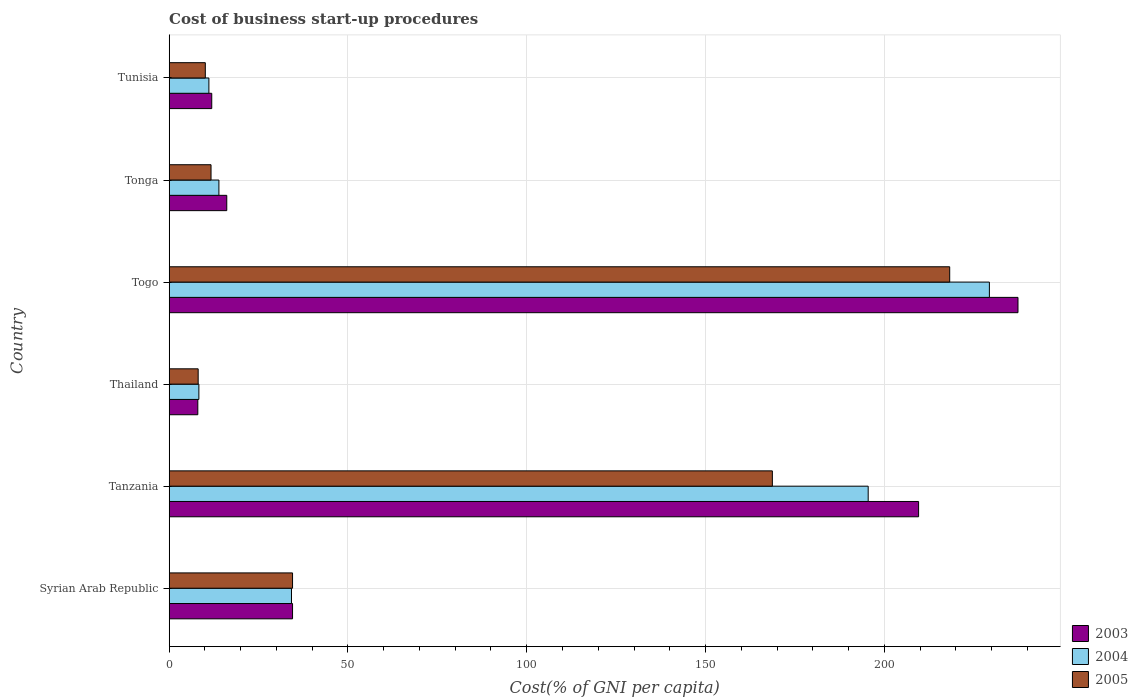How many different coloured bars are there?
Make the answer very short. 3. Are the number of bars per tick equal to the number of legend labels?
Make the answer very short. Yes. How many bars are there on the 3rd tick from the bottom?
Offer a terse response. 3. What is the label of the 5th group of bars from the top?
Your answer should be compact. Tanzania. What is the cost of business start-up procedures in 2004 in Togo?
Your response must be concise. 229.4. Across all countries, what is the maximum cost of business start-up procedures in 2003?
Your response must be concise. 237.4. In which country was the cost of business start-up procedures in 2003 maximum?
Your answer should be very brief. Togo. In which country was the cost of business start-up procedures in 2004 minimum?
Your response must be concise. Thailand. What is the total cost of business start-up procedures in 2003 in the graph?
Offer a terse response. 517.5. What is the difference between the cost of business start-up procedures in 2003 in Tonga and that in Tunisia?
Ensure brevity in your answer.  4.2. What is the difference between the cost of business start-up procedures in 2003 in Thailand and the cost of business start-up procedures in 2005 in Tunisia?
Offer a very short reply. -2.1. What is the average cost of business start-up procedures in 2005 per country?
Offer a very short reply. 75.23. What is the difference between the cost of business start-up procedures in 2003 and cost of business start-up procedures in 2005 in Tunisia?
Provide a succinct answer. 1.8. In how many countries, is the cost of business start-up procedures in 2004 greater than 20 %?
Your answer should be very brief. 3. What is the ratio of the cost of business start-up procedures in 2004 in Syrian Arab Republic to that in Thailand?
Your answer should be very brief. 4.12. Is the cost of business start-up procedures in 2003 in Togo less than that in Tunisia?
Make the answer very short. No. Is the difference between the cost of business start-up procedures in 2003 in Thailand and Tonga greater than the difference between the cost of business start-up procedures in 2005 in Thailand and Tonga?
Give a very brief answer. No. What is the difference between the highest and the second highest cost of business start-up procedures in 2005?
Give a very brief answer. 49.6. What is the difference between the highest and the lowest cost of business start-up procedures in 2005?
Keep it short and to the point. 210.2. Is the sum of the cost of business start-up procedures in 2005 in Tanzania and Tonga greater than the maximum cost of business start-up procedures in 2004 across all countries?
Ensure brevity in your answer.  No. Is it the case that in every country, the sum of the cost of business start-up procedures in 2005 and cost of business start-up procedures in 2004 is greater than the cost of business start-up procedures in 2003?
Keep it short and to the point. Yes. How many bars are there?
Offer a terse response. 18. Are all the bars in the graph horizontal?
Your answer should be very brief. Yes. Are the values on the major ticks of X-axis written in scientific E-notation?
Ensure brevity in your answer.  No. Does the graph contain any zero values?
Provide a succinct answer. No. Does the graph contain grids?
Give a very brief answer. Yes. Where does the legend appear in the graph?
Keep it short and to the point. Bottom right. How are the legend labels stacked?
Ensure brevity in your answer.  Vertical. What is the title of the graph?
Your response must be concise. Cost of business start-up procedures. What is the label or title of the X-axis?
Provide a short and direct response. Cost(% of GNI per capita). What is the Cost(% of GNI per capita) of 2003 in Syrian Arab Republic?
Your answer should be very brief. 34.5. What is the Cost(% of GNI per capita) of 2004 in Syrian Arab Republic?
Ensure brevity in your answer.  34.2. What is the Cost(% of GNI per capita) of 2005 in Syrian Arab Republic?
Keep it short and to the point. 34.5. What is the Cost(% of GNI per capita) of 2003 in Tanzania?
Offer a very short reply. 209.6. What is the Cost(% of GNI per capita) in 2004 in Tanzania?
Keep it short and to the point. 195.5. What is the Cost(% of GNI per capita) of 2005 in Tanzania?
Your response must be concise. 168.7. What is the Cost(% of GNI per capita) of 2003 in Togo?
Offer a terse response. 237.4. What is the Cost(% of GNI per capita) of 2004 in Togo?
Provide a succinct answer. 229.4. What is the Cost(% of GNI per capita) of 2005 in Togo?
Offer a very short reply. 218.3. What is the Cost(% of GNI per capita) of 2003 in Tonga?
Your answer should be very brief. 16.1. What is the Cost(% of GNI per capita) of 2005 in Tonga?
Provide a succinct answer. 11.7. What is the Cost(% of GNI per capita) of 2003 in Tunisia?
Keep it short and to the point. 11.9. What is the Cost(% of GNI per capita) of 2005 in Tunisia?
Your answer should be compact. 10.1. Across all countries, what is the maximum Cost(% of GNI per capita) in 2003?
Offer a very short reply. 237.4. Across all countries, what is the maximum Cost(% of GNI per capita) of 2004?
Your response must be concise. 229.4. Across all countries, what is the maximum Cost(% of GNI per capita) of 2005?
Your answer should be compact. 218.3. Across all countries, what is the minimum Cost(% of GNI per capita) in 2005?
Your answer should be very brief. 8.1. What is the total Cost(% of GNI per capita) in 2003 in the graph?
Your answer should be compact. 517.5. What is the total Cost(% of GNI per capita) of 2004 in the graph?
Ensure brevity in your answer.  492.4. What is the total Cost(% of GNI per capita) of 2005 in the graph?
Provide a succinct answer. 451.4. What is the difference between the Cost(% of GNI per capita) in 2003 in Syrian Arab Republic and that in Tanzania?
Provide a succinct answer. -175.1. What is the difference between the Cost(% of GNI per capita) of 2004 in Syrian Arab Republic and that in Tanzania?
Provide a succinct answer. -161.3. What is the difference between the Cost(% of GNI per capita) in 2005 in Syrian Arab Republic and that in Tanzania?
Make the answer very short. -134.2. What is the difference between the Cost(% of GNI per capita) in 2004 in Syrian Arab Republic and that in Thailand?
Provide a short and direct response. 25.9. What is the difference between the Cost(% of GNI per capita) in 2005 in Syrian Arab Republic and that in Thailand?
Ensure brevity in your answer.  26.4. What is the difference between the Cost(% of GNI per capita) of 2003 in Syrian Arab Republic and that in Togo?
Provide a succinct answer. -202.9. What is the difference between the Cost(% of GNI per capita) of 2004 in Syrian Arab Republic and that in Togo?
Your answer should be compact. -195.2. What is the difference between the Cost(% of GNI per capita) of 2005 in Syrian Arab Republic and that in Togo?
Provide a succinct answer. -183.8. What is the difference between the Cost(% of GNI per capita) in 2004 in Syrian Arab Republic and that in Tonga?
Your response must be concise. 20.3. What is the difference between the Cost(% of GNI per capita) of 2005 in Syrian Arab Republic and that in Tonga?
Ensure brevity in your answer.  22.8. What is the difference between the Cost(% of GNI per capita) of 2003 in Syrian Arab Republic and that in Tunisia?
Provide a short and direct response. 22.6. What is the difference between the Cost(% of GNI per capita) of 2004 in Syrian Arab Republic and that in Tunisia?
Your answer should be very brief. 23.1. What is the difference between the Cost(% of GNI per capita) of 2005 in Syrian Arab Republic and that in Tunisia?
Keep it short and to the point. 24.4. What is the difference between the Cost(% of GNI per capita) in 2003 in Tanzania and that in Thailand?
Offer a terse response. 201.6. What is the difference between the Cost(% of GNI per capita) of 2004 in Tanzania and that in Thailand?
Give a very brief answer. 187.2. What is the difference between the Cost(% of GNI per capita) in 2005 in Tanzania and that in Thailand?
Make the answer very short. 160.6. What is the difference between the Cost(% of GNI per capita) of 2003 in Tanzania and that in Togo?
Provide a succinct answer. -27.8. What is the difference between the Cost(% of GNI per capita) in 2004 in Tanzania and that in Togo?
Offer a very short reply. -33.9. What is the difference between the Cost(% of GNI per capita) in 2005 in Tanzania and that in Togo?
Provide a succinct answer. -49.6. What is the difference between the Cost(% of GNI per capita) of 2003 in Tanzania and that in Tonga?
Ensure brevity in your answer.  193.5. What is the difference between the Cost(% of GNI per capita) in 2004 in Tanzania and that in Tonga?
Your answer should be compact. 181.6. What is the difference between the Cost(% of GNI per capita) in 2005 in Tanzania and that in Tonga?
Ensure brevity in your answer.  157. What is the difference between the Cost(% of GNI per capita) in 2003 in Tanzania and that in Tunisia?
Make the answer very short. 197.7. What is the difference between the Cost(% of GNI per capita) of 2004 in Tanzania and that in Tunisia?
Provide a succinct answer. 184.4. What is the difference between the Cost(% of GNI per capita) of 2005 in Tanzania and that in Tunisia?
Your response must be concise. 158.6. What is the difference between the Cost(% of GNI per capita) of 2003 in Thailand and that in Togo?
Your answer should be very brief. -229.4. What is the difference between the Cost(% of GNI per capita) in 2004 in Thailand and that in Togo?
Your response must be concise. -221.1. What is the difference between the Cost(% of GNI per capita) in 2005 in Thailand and that in Togo?
Keep it short and to the point. -210.2. What is the difference between the Cost(% of GNI per capita) in 2003 in Thailand and that in Tonga?
Your response must be concise. -8.1. What is the difference between the Cost(% of GNI per capita) in 2005 in Thailand and that in Tonga?
Provide a succinct answer. -3.6. What is the difference between the Cost(% of GNI per capita) of 2004 in Thailand and that in Tunisia?
Make the answer very short. -2.8. What is the difference between the Cost(% of GNI per capita) of 2005 in Thailand and that in Tunisia?
Ensure brevity in your answer.  -2. What is the difference between the Cost(% of GNI per capita) in 2003 in Togo and that in Tonga?
Keep it short and to the point. 221.3. What is the difference between the Cost(% of GNI per capita) of 2004 in Togo and that in Tonga?
Make the answer very short. 215.5. What is the difference between the Cost(% of GNI per capita) of 2005 in Togo and that in Tonga?
Your response must be concise. 206.6. What is the difference between the Cost(% of GNI per capita) in 2003 in Togo and that in Tunisia?
Give a very brief answer. 225.5. What is the difference between the Cost(% of GNI per capita) in 2004 in Togo and that in Tunisia?
Offer a terse response. 218.3. What is the difference between the Cost(% of GNI per capita) in 2005 in Togo and that in Tunisia?
Your answer should be compact. 208.2. What is the difference between the Cost(% of GNI per capita) in 2004 in Tonga and that in Tunisia?
Your answer should be compact. 2.8. What is the difference between the Cost(% of GNI per capita) of 2003 in Syrian Arab Republic and the Cost(% of GNI per capita) of 2004 in Tanzania?
Your answer should be compact. -161. What is the difference between the Cost(% of GNI per capita) in 2003 in Syrian Arab Republic and the Cost(% of GNI per capita) in 2005 in Tanzania?
Offer a terse response. -134.2. What is the difference between the Cost(% of GNI per capita) of 2004 in Syrian Arab Republic and the Cost(% of GNI per capita) of 2005 in Tanzania?
Provide a short and direct response. -134.5. What is the difference between the Cost(% of GNI per capita) of 2003 in Syrian Arab Republic and the Cost(% of GNI per capita) of 2004 in Thailand?
Give a very brief answer. 26.2. What is the difference between the Cost(% of GNI per capita) of 2003 in Syrian Arab Republic and the Cost(% of GNI per capita) of 2005 in Thailand?
Provide a succinct answer. 26.4. What is the difference between the Cost(% of GNI per capita) in 2004 in Syrian Arab Republic and the Cost(% of GNI per capita) in 2005 in Thailand?
Your answer should be compact. 26.1. What is the difference between the Cost(% of GNI per capita) in 2003 in Syrian Arab Republic and the Cost(% of GNI per capita) in 2004 in Togo?
Make the answer very short. -194.9. What is the difference between the Cost(% of GNI per capita) of 2003 in Syrian Arab Republic and the Cost(% of GNI per capita) of 2005 in Togo?
Offer a terse response. -183.8. What is the difference between the Cost(% of GNI per capita) in 2004 in Syrian Arab Republic and the Cost(% of GNI per capita) in 2005 in Togo?
Make the answer very short. -184.1. What is the difference between the Cost(% of GNI per capita) in 2003 in Syrian Arab Republic and the Cost(% of GNI per capita) in 2004 in Tonga?
Provide a short and direct response. 20.6. What is the difference between the Cost(% of GNI per capita) of 2003 in Syrian Arab Republic and the Cost(% of GNI per capita) of 2005 in Tonga?
Ensure brevity in your answer.  22.8. What is the difference between the Cost(% of GNI per capita) of 2004 in Syrian Arab Republic and the Cost(% of GNI per capita) of 2005 in Tonga?
Your response must be concise. 22.5. What is the difference between the Cost(% of GNI per capita) in 2003 in Syrian Arab Republic and the Cost(% of GNI per capita) in 2004 in Tunisia?
Provide a short and direct response. 23.4. What is the difference between the Cost(% of GNI per capita) in 2003 in Syrian Arab Republic and the Cost(% of GNI per capita) in 2005 in Tunisia?
Provide a short and direct response. 24.4. What is the difference between the Cost(% of GNI per capita) of 2004 in Syrian Arab Republic and the Cost(% of GNI per capita) of 2005 in Tunisia?
Keep it short and to the point. 24.1. What is the difference between the Cost(% of GNI per capita) in 2003 in Tanzania and the Cost(% of GNI per capita) in 2004 in Thailand?
Your answer should be very brief. 201.3. What is the difference between the Cost(% of GNI per capita) of 2003 in Tanzania and the Cost(% of GNI per capita) of 2005 in Thailand?
Offer a terse response. 201.5. What is the difference between the Cost(% of GNI per capita) in 2004 in Tanzania and the Cost(% of GNI per capita) in 2005 in Thailand?
Your answer should be very brief. 187.4. What is the difference between the Cost(% of GNI per capita) in 2003 in Tanzania and the Cost(% of GNI per capita) in 2004 in Togo?
Make the answer very short. -19.8. What is the difference between the Cost(% of GNI per capita) in 2004 in Tanzania and the Cost(% of GNI per capita) in 2005 in Togo?
Provide a succinct answer. -22.8. What is the difference between the Cost(% of GNI per capita) in 2003 in Tanzania and the Cost(% of GNI per capita) in 2004 in Tonga?
Make the answer very short. 195.7. What is the difference between the Cost(% of GNI per capita) in 2003 in Tanzania and the Cost(% of GNI per capita) in 2005 in Tonga?
Make the answer very short. 197.9. What is the difference between the Cost(% of GNI per capita) of 2004 in Tanzania and the Cost(% of GNI per capita) of 2005 in Tonga?
Offer a very short reply. 183.8. What is the difference between the Cost(% of GNI per capita) in 2003 in Tanzania and the Cost(% of GNI per capita) in 2004 in Tunisia?
Your answer should be very brief. 198.5. What is the difference between the Cost(% of GNI per capita) of 2003 in Tanzania and the Cost(% of GNI per capita) of 2005 in Tunisia?
Offer a terse response. 199.5. What is the difference between the Cost(% of GNI per capita) in 2004 in Tanzania and the Cost(% of GNI per capita) in 2005 in Tunisia?
Keep it short and to the point. 185.4. What is the difference between the Cost(% of GNI per capita) in 2003 in Thailand and the Cost(% of GNI per capita) in 2004 in Togo?
Your answer should be very brief. -221.4. What is the difference between the Cost(% of GNI per capita) in 2003 in Thailand and the Cost(% of GNI per capita) in 2005 in Togo?
Keep it short and to the point. -210.3. What is the difference between the Cost(% of GNI per capita) of 2004 in Thailand and the Cost(% of GNI per capita) of 2005 in Togo?
Make the answer very short. -210. What is the difference between the Cost(% of GNI per capita) in 2003 in Thailand and the Cost(% of GNI per capita) in 2004 in Tonga?
Provide a succinct answer. -5.9. What is the difference between the Cost(% of GNI per capita) of 2004 in Thailand and the Cost(% of GNI per capita) of 2005 in Tonga?
Make the answer very short. -3.4. What is the difference between the Cost(% of GNI per capita) in 2003 in Thailand and the Cost(% of GNI per capita) in 2005 in Tunisia?
Your answer should be compact. -2.1. What is the difference between the Cost(% of GNI per capita) of 2003 in Togo and the Cost(% of GNI per capita) of 2004 in Tonga?
Offer a very short reply. 223.5. What is the difference between the Cost(% of GNI per capita) in 2003 in Togo and the Cost(% of GNI per capita) in 2005 in Tonga?
Provide a short and direct response. 225.7. What is the difference between the Cost(% of GNI per capita) in 2004 in Togo and the Cost(% of GNI per capita) in 2005 in Tonga?
Your answer should be very brief. 217.7. What is the difference between the Cost(% of GNI per capita) of 2003 in Togo and the Cost(% of GNI per capita) of 2004 in Tunisia?
Give a very brief answer. 226.3. What is the difference between the Cost(% of GNI per capita) of 2003 in Togo and the Cost(% of GNI per capita) of 2005 in Tunisia?
Your answer should be compact. 227.3. What is the difference between the Cost(% of GNI per capita) of 2004 in Togo and the Cost(% of GNI per capita) of 2005 in Tunisia?
Make the answer very short. 219.3. What is the difference between the Cost(% of GNI per capita) in 2004 in Tonga and the Cost(% of GNI per capita) in 2005 in Tunisia?
Your answer should be compact. 3.8. What is the average Cost(% of GNI per capita) of 2003 per country?
Make the answer very short. 86.25. What is the average Cost(% of GNI per capita) in 2004 per country?
Give a very brief answer. 82.07. What is the average Cost(% of GNI per capita) of 2005 per country?
Give a very brief answer. 75.23. What is the difference between the Cost(% of GNI per capita) in 2003 and Cost(% of GNI per capita) in 2005 in Syrian Arab Republic?
Keep it short and to the point. 0. What is the difference between the Cost(% of GNI per capita) of 2004 and Cost(% of GNI per capita) of 2005 in Syrian Arab Republic?
Provide a short and direct response. -0.3. What is the difference between the Cost(% of GNI per capita) of 2003 and Cost(% of GNI per capita) of 2004 in Tanzania?
Offer a very short reply. 14.1. What is the difference between the Cost(% of GNI per capita) in 2003 and Cost(% of GNI per capita) in 2005 in Tanzania?
Ensure brevity in your answer.  40.9. What is the difference between the Cost(% of GNI per capita) in 2004 and Cost(% of GNI per capita) in 2005 in Tanzania?
Give a very brief answer. 26.8. What is the difference between the Cost(% of GNI per capita) of 2003 and Cost(% of GNI per capita) of 2005 in Thailand?
Provide a short and direct response. -0.1. What is the difference between the Cost(% of GNI per capita) in 2004 and Cost(% of GNI per capita) in 2005 in Thailand?
Your response must be concise. 0.2. What is the difference between the Cost(% of GNI per capita) in 2003 and Cost(% of GNI per capita) in 2004 in Togo?
Your answer should be compact. 8. What is the difference between the Cost(% of GNI per capita) of 2003 and Cost(% of GNI per capita) of 2005 in Togo?
Your answer should be very brief. 19.1. What is the difference between the Cost(% of GNI per capita) of 2004 and Cost(% of GNI per capita) of 2005 in Togo?
Offer a very short reply. 11.1. What is the difference between the Cost(% of GNI per capita) of 2004 and Cost(% of GNI per capita) of 2005 in Tonga?
Keep it short and to the point. 2.2. What is the difference between the Cost(% of GNI per capita) in 2004 and Cost(% of GNI per capita) in 2005 in Tunisia?
Your answer should be compact. 1. What is the ratio of the Cost(% of GNI per capita) in 2003 in Syrian Arab Republic to that in Tanzania?
Offer a terse response. 0.16. What is the ratio of the Cost(% of GNI per capita) of 2004 in Syrian Arab Republic to that in Tanzania?
Make the answer very short. 0.17. What is the ratio of the Cost(% of GNI per capita) in 2005 in Syrian Arab Republic to that in Tanzania?
Your answer should be compact. 0.2. What is the ratio of the Cost(% of GNI per capita) in 2003 in Syrian Arab Republic to that in Thailand?
Give a very brief answer. 4.31. What is the ratio of the Cost(% of GNI per capita) of 2004 in Syrian Arab Republic to that in Thailand?
Provide a succinct answer. 4.12. What is the ratio of the Cost(% of GNI per capita) of 2005 in Syrian Arab Republic to that in Thailand?
Your answer should be compact. 4.26. What is the ratio of the Cost(% of GNI per capita) in 2003 in Syrian Arab Republic to that in Togo?
Your answer should be compact. 0.15. What is the ratio of the Cost(% of GNI per capita) of 2004 in Syrian Arab Republic to that in Togo?
Provide a succinct answer. 0.15. What is the ratio of the Cost(% of GNI per capita) in 2005 in Syrian Arab Republic to that in Togo?
Make the answer very short. 0.16. What is the ratio of the Cost(% of GNI per capita) of 2003 in Syrian Arab Republic to that in Tonga?
Your answer should be very brief. 2.14. What is the ratio of the Cost(% of GNI per capita) of 2004 in Syrian Arab Republic to that in Tonga?
Your answer should be compact. 2.46. What is the ratio of the Cost(% of GNI per capita) of 2005 in Syrian Arab Republic to that in Tonga?
Provide a short and direct response. 2.95. What is the ratio of the Cost(% of GNI per capita) in 2003 in Syrian Arab Republic to that in Tunisia?
Keep it short and to the point. 2.9. What is the ratio of the Cost(% of GNI per capita) of 2004 in Syrian Arab Republic to that in Tunisia?
Make the answer very short. 3.08. What is the ratio of the Cost(% of GNI per capita) in 2005 in Syrian Arab Republic to that in Tunisia?
Your answer should be compact. 3.42. What is the ratio of the Cost(% of GNI per capita) in 2003 in Tanzania to that in Thailand?
Provide a succinct answer. 26.2. What is the ratio of the Cost(% of GNI per capita) of 2004 in Tanzania to that in Thailand?
Your response must be concise. 23.55. What is the ratio of the Cost(% of GNI per capita) of 2005 in Tanzania to that in Thailand?
Give a very brief answer. 20.83. What is the ratio of the Cost(% of GNI per capita) in 2003 in Tanzania to that in Togo?
Give a very brief answer. 0.88. What is the ratio of the Cost(% of GNI per capita) in 2004 in Tanzania to that in Togo?
Give a very brief answer. 0.85. What is the ratio of the Cost(% of GNI per capita) in 2005 in Tanzania to that in Togo?
Provide a short and direct response. 0.77. What is the ratio of the Cost(% of GNI per capita) of 2003 in Tanzania to that in Tonga?
Keep it short and to the point. 13.02. What is the ratio of the Cost(% of GNI per capita) of 2004 in Tanzania to that in Tonga?
Offer a terse response. 14.06. What is the ratio of the Cost(% of GNI per capita) of 2005 in Tanzania to that in Tonga?
Provide a succinct answer. 14.42. What is the ratio of the Cost(% of GNI per capita) of 2003 in Tanzania to that in Tunisia?
Keep it short and to the point. 17.61. What is the ratio of the Cost(% of GNI per capita) of 2004 in Tanzania to that in Tunisia?
Offer a very short reply. 17.61. What is the ratio of the Cost(% of GNI per capita) in 2005 in Tanzania to that in Tunisia?
Provide a succinct answer. 16.7. What is the ratio of the Cost(% of GNI per capita) of 2003 in Thailand to that in Togo?
Your answer should be very brief. 0.03. What is the ratio of the Cost(% of GNI per capita) of 2004 in Thailand to that in Togo?
Your answer should be compact. 0.04. What is the ratio of the Cost(% of GNI per capita) of 2005 in Thailand to that in Togo?
Your answer should be compact. 0.04. What is the ratio of the Cost(% of GNI per capita) of 2003 in Thailand to that in Tonga?
Provide a succinct answer. 0.5. What is the ratio of the Cost(% of GNI per capita) in 2004 in Thailand to that in Tonga?
Your answer should be compact. 0.6. What is the ratio of the Cost(% of GNI per capita) of 2005 in Thailand to that in Tonga?
Provide a succinct answer. 0.69. What is the ratio of the Cost(% of GNI per capita) in 2003 in Thailand to that in Tunisia?
Make the answer very short. 0.67. What is the ratio of the Cost(% of GNI per capita) in 2004 in Thailand to that in Tunisia?
Your response must be concise. 0.75. What is the ratio of the Cost(% of GNI per capita) in 2005 in Thailand to that in Tunisia?
Your answer should be very brief. 0.8. What is the ratio of the Cost(% of GNI per capita) in 2003 in Togo to that in Tonga?
Offer a terse response. 14.75. What is the ratio of the Cost(% of GNI per capita) in 2004 in Togo to that in Tonga?
Your answer should be very brief. 16.5. What is the ratio of the Cost(% of GNI per capita) in 2005 in Togo to that in Tonga?
Provide a succinct answer. 18.66. What is the ratio of the Cost(% of GNI per capita) of 2003 in Togo to that in Tunisia?
Your answer should be very brief. 19.95. What is the ratio of the Cost(% of GNI per capita) in 2004 in Togo to that in Tunisia?
Keep it short and to the point. 20.67. What is the ratio of the Cost(% of GNI per capita) of 2005 in Togo to that in Tunisia?
Your response must be concise. 21.61. What is the ratio of the Cost(% of GNI per capita) of 2003 in Tonga to that in Tunisia?
Make the answer very short. 1.35. What is the ratio of the Cost(% of GNI per capita) in 2004 in Tonga to that in Tunisia?
Offer a terse response. 1.25. What is the ratio of the Cost(% of GNI per capita) of 2005 in Tonga to that in Tunisia?
Keep it short and to the point. 1.16. What is the difference between the highest and the second highest Cost(% of GNI per capita) of 2003?
Your answer should be compact. 27.8. What is the difference between the highest and the second highest Cost(% of GNI per capita) in 2004?
Keep it short and to the point. 33.9. What is the difference between the highest and the second highest Cost(% of GNI per capita) of 2005?
Ensure brevity in your answer.  49.6. What is the difference between the highest and the lowest Cost(% of GNI per capita) of 2003?
Keep it short and to the point. 229.4. What is the difference between the highest and the lowest Cost(% of GNI per capita) of 2004?
Provide a succinct answer. 221.1. What is the difference between the highest and the lowest Cost(% of GNI per capita) in 2005?
Ensure brevity in your answer.  210.2. 